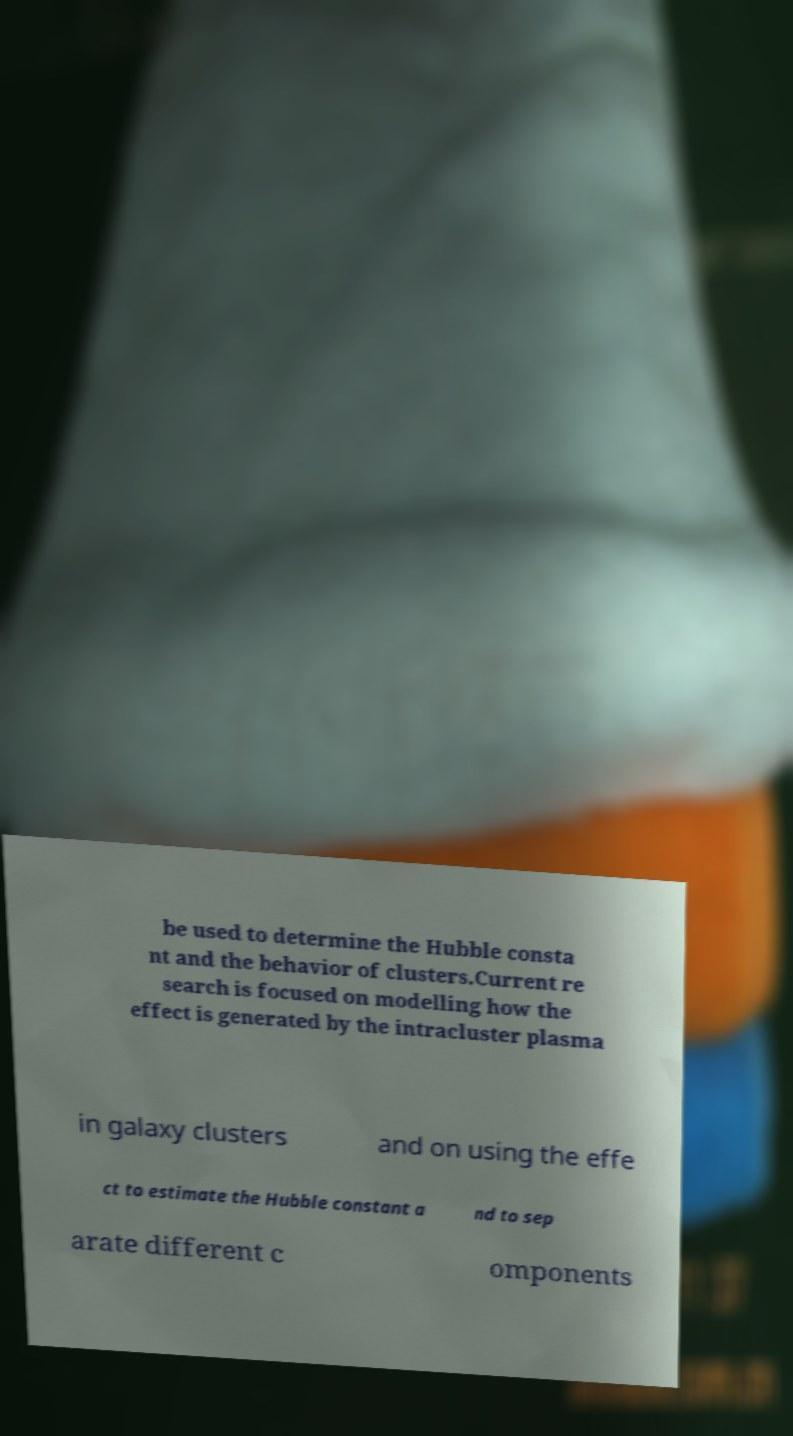Please read and relay the text visible in this image. What does it say? be used to determine the Hubble consta nt and the behavior of clusters.Current re search is focused on modelling how the effect is generated by the intracluster plasma in galaxy clusters and on using the effe ct to estimate the Hubble constant a nd to sep arate different c omponents 